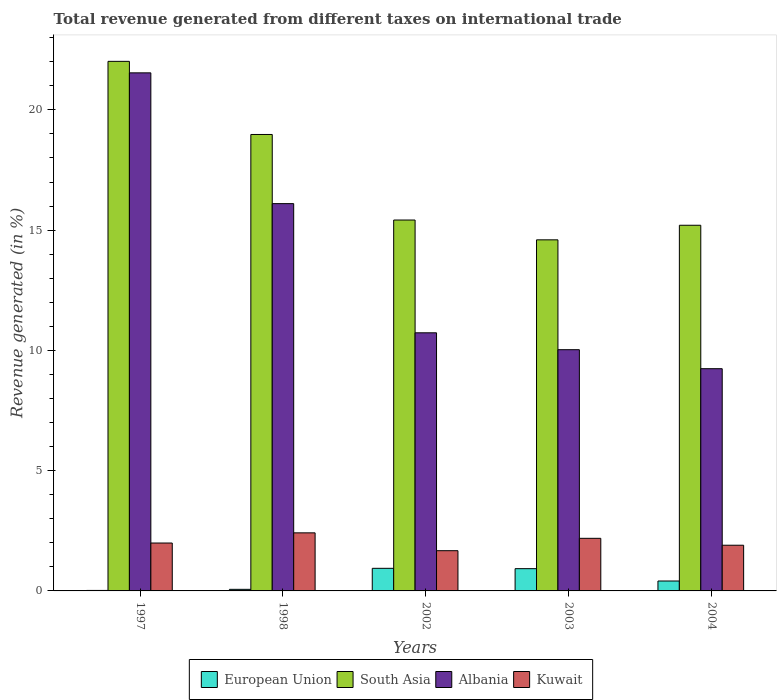How many different coloured bars are there?
Your answer should be compact. 4. How many groups of bars are there?
Provide a short and direct response. 5. Are the number of bars per tick equal to the number of legend labels?
Keep it short and to the point. Yes. How many bars are there on the 2nd tick from the left?
Ensure brevity in your answer.  4. What is the total revenue generated in South Asia in 2002?
Offer a terse response. 15.42. Across all years, what is the maximum total revenue generated in Albania?
Your answer should be compact. 21.54. Across all years, what is the minimum total revenue generated in Albania?
Offer a very short reply. 9.24. In which year was the total revenue generated in Kuwait maximum?
Provide a succinct answer. 1998. In which year was the total revenue generated in European Union minimum?
Ensure brevity in your answer.  1997. What is the total total revenue generated in South Asia in the graph?
Offer a very short reply. 86.21. What is the difference between the total revenue generated in South Asia in 1998 and that in 2004?
Your answer should be compact. 3.77. What is the difference between the total revenue generated in Albania in 2003 and the total revenue generated in South Asia in 1997?
Offer a very short reply. -11.99. What is the average total revenue generated in Kuwait per year?
Offer a very short reply. 2.03. In the year 1998, what is the difference between the total revenue generated in Albania and total revenue generated in European Union?
Offer a very short reply. 16.04. In how many years, is the total revenue generated in Kuwait greater than 20 %?
Offer a terse response. 0. What is the ratio of the total revenue generated in Albania in 2002 to that in 2003?
Your response must be concise. 1.07. What is the difference between the highest and the second highest total revenue generated in European Union?
Make the answer very short. 0.01. What is the difference between the highest and the lowest total revenue generated in South Asia?
Ensure brevity in your answer.  7.42. In how many years, is the total revenue generated in South Asia greater than the average total revenue generated in South Asia taken over all years?
Make the answer very short. 2. Is the sum of the total revenue generated in South Asia in 1997 and 2003 greater than the maximum total revenue generated in Albania across all years?
Offer a terse response. Yes. Is it the case that in every year, the sum of the total revenue generated in Kuwait and total revenue generated in European Union is greater than the sum of total revenue generated in Albania and total revenue generated in South Asia?
Offer a very short reply. Yes. What does the 1st bar from the left in 1998 represents?
Your answer should be compact. European Union. How many bars are there?
Provide a short and direct response. 20. What is the difference between two consecutive major ticks on the Y-axis?
Make the answer very short. 5. Does the graph contain any zero values?
Your answer should be compact. No. Where does the legend appear in the graph?
Your answer should be compact. Bottom center. How many legend labels are there?
Offer a very short reply. 4. How are the legend labels stacked?
Offer a very short reply. Horizontal. What is the title of the graph?
Your answer should be compact. Total revenue generated from different taxes on international trade. What is the label or title of the X-axis?
Keep it short and to the point. Years. What is the label or title of the Y-axis?
Your answer should be very brief. Revenue generated (in %). What is the Revenue generated (in %) in European Union in 1997?
Your answer should be compact. 0.02. What is the Revenue generated (in %) of South Asia in 1997?
Ensure brevity in your answer.  22.02. What is the Revenue generated (in %) in Albania in 1997?
Give a very brief answer. 21.54. What is the Revenue generated (in %) of Kuwait in 1997?
Your response must be concise. 1.99. What is the Revenue generated (in %) of European Union in 1998?
Your answer should be very brief. 0.07. What is the Revenue generated (in %) in South Asia in 1998?
Ensure brevity in your answer.  18.98. What is the Revenue generated (in %) in Albania in 1998?
Give a very brief answer. 16.1. What is the Revenue generated (in %) in Kuwait in 1998?
Provide a succinct answer. 2.41. What is the Revenue generated (in %) in European Union in 2002?
Offer a very short reply. 0.94. What is the Revenue generated (in %) of South Asia in 2002?
Provide a short and direct response. 15.42. What is the Revenue generated (in %) in Albania in 2002?
Provide a succinct answer. 10.73. What is the Revenue generated (in %) in Kuwait in 2002?
Ensure brevity in your answer.  1.67. What is the Revenue generated (in %) of European Union in 2003?
Give a very brief answer. 0.93. What is the Revenue generated (in %) in South Asia in 2003?
Give a very brief answer. 14.6. What is the Revenue generated (in %) of Albania in 2003?
Offer a very short reply. 10.03. What is the Revenue generated (in %) of Kuwait in 2003?
Make the answer very short. 2.19. What is the Revenue generated (in %) in European Union in 2004?
Provide a succinct answer. 0.41. What is the Revenue generated (in %) in South Asia in 2004?
Offer a very short reply. 15.2. What is the Revenue generated (in %) of Albania in 2004?
Your answer should be very brief. 9.24. What is the Revenue generated (in %) of Kuwait in 2004?
Your answer should be very brief. 1.9. Across all years, what is the maximum Revenue generated (in %) of European Union?
Provide a short and direct response. 0.94. Across all years, what is the maximum Revenue generated (in %) of South Asia?
Provide a succinct answer. 22.02. Across all years, what is the maximum Revenue generated (in %) in Albania?
Your answer should be very brief. 21.54. Across all years, what is the maximum Revenue generated (in %) in Kuwait?
Provide a short and direct response. 2.41. Across all years, what is the minimum Revenue generated (in %) of European Union?
Your answer should be compact. 0.02. Across all years, what is the minimum Revenue generated (in %) of South Asia?
Keep it short and to the point. 14.6. Across all years, what is the minimum Revenue generated (in %) of Albania?
Offer a terse response. 9.24. Across all years, what is the minimum Revenue generated (in %) in Kuwait?
Make the answer very short. 1.67. What is the total Revenue generated (in %) in European Union in the graph?
Provide a short and direct response. 2.36. What is the total Revenue generated (in %) of South Asia in the graph?
Provide a short and direct response. 86.21. What is the total Revenue generated (in %) in Albania in the graph?
Give a very brief answer. 67.64. What is the total Revenue generated (in %) in Kuwait in the graph?
Your response must be concise. 10.16. What is the difference between the Revenue generated (in %) of European Union in 1997 and that in 1998?
Give a very brief answer. -0.05. What is the difference between the Revenue generated (in %) of South Asia in 1997 and that in 1998?
Keep it short and to the point. 3.04. What is the difference between the Revenue generated (in %) in Albania in 1997 and that in 1998?
Your answer should be compact. 5.44. What is the difference between the Revenue generated (in %) in Kuwait in 1997 and that in 1998?
Offer a terse response. -0.42. What is the difference between the Revenue generated (in %) of European Union in 1997 and that in 2002?
Your answer should be very brief. -0.92. What is the difference between the Revenue generated (in %) in South Asia in 1997 and that in 2002?
Offer a very short reply. 6.6. What is the difference between the Revenue generated (in %) of Albania in 1997 and that in 2002?
Ensure brevity in your answer.  10.81. What is the difference between the Revenue generated (in %) in Kuwait in 1997 and that in 2002?
Your response must be concise. 0.32. What is the difference between the Revenue generated (in %) in European Union in 1997 and that in 2003?
Offer a terse response. -0.9. What is the difference between the Revenue generated (in %) of South Asia in 1997 and that in 2003?
Ensure brevity in your answer.  7.42. What is the difference between the Revenue generated (in %) of Albania in 1997 and that in 2003?
Offer a terse response. 11.51. What is the difference between the Revenue generated (in %) in Kuwait in 1997 and that in 2003?
Your response must be concise. -0.2. What is the difference between the Revenue generated (in %) in European Union in 1997 and that in 2004?
Your answer should be compact. -0.39. What is the difference between the Revenue generated (in %) in South Asia in 1997 and that in 2004?
Provide a succinct answer. 6.81. What is the difference between the Revenue generated (in %) in Albania in 1997 and that in 2004?
Your answer should be compact. 12.3. What is the difference between the Revenue generated (in %) in Kuwait in 1997 and that in 2004?
Your answer should be compact. 0.09. What is the difference between the Revenue generated (in %) in European Union in 1998 and that in 2002?
Ensure brevity in your answer.  -0.87. What is the difference between the Revenue generated (in %) in South Asia in 1998 and that in 2002?
Give a very brief answer. 3.56. What is the difference between the Revenue generated (in %) of Albania in 1998 and that in 2002?
Keep it short and to the point. 5.37. What is the difference between the Revenue generated (in %) of Kuwait in 1998 and that in 2002?
Offer a terse response. 0.74. What is the difference between the Revenue generated (in %) in European Union in 1998 and that in 2003?
Offer a terse response. -0.86. What is the difference between the Revenue generated (in %) of South Asia in 1998 and that in 2003?
Make the answer very short. 4.38. What is the difference between the Revenue generated (in %) in Albania in 1998 and that in 2003?
Your answer should be very brief. 6.07. What is the difference between the Revenue generated (in %) in Kuwait in 1998 and that in 2003?
Your answer should be very brief. 0.23. What is the difference between the Revenue generated (in %) in European Union in 1998 and that in 2004?
Your answer should be compact. -0.35. What is the difference between the Revenue generated (in %) in South Asia in 1998 and that in 2004?
Your response must be concise. 3.77. What is the difference between the Revenue generated (in %) of Albania in 1998 and that in 2004?
Make the answer very short. 6.86. What is the difference between the Revenue generated (in %) of Kuwait in 1998 and that in 2004?
Provide a succinct answer. 0.51. What is the difference between the Revenue generated (in %) in European Union in 2002 and that in 2003?
Your answer should be very brief. 0.01. What is the difference between the Revenue generated (in %) of South Asia in 2002 and that in 2003?
Offer a terse response. 0.82. What is the difference between the Revenue generated (in %) of Albania in 2002 and that in 2003?
Keep it short and to the point. 0.7. What is the difference between the Revenue generated (in %) of Kuwait in 2002 and that in 2003?
Your answer should be very brief. -0.52. What is the difference between the Revenue generated (in %) in European Union in 2002 and that in 2004?
Give a very brief answer. 0.53. What is the difference between the Revenue generated (in %) in South Asia in 2002 and that in 2004?
Your response must be concise. 0.22. What is the difference between the Revenue generated (in %) in Albania in 2002 and that in 2004?
Offer a very short reply. 1.49. What is the difference between the Revenue generated (in %) of Kuwait in 2002 and that in 2004?
Offer a terse response. -0.23. What is the difference between the Revenue generated (in %) in European Union in 2003 and that in 2004?
Your response must be concise. 0.51. What is the difference between the Revenue generated (in %) in South Asia in 2003 and that in 2004?
Keep it short and to the point. -0.61. What is the difference between the Revenue generated (in %) in Albania in 2003 and that in 2004?
Offer a terse response. 0.79. What is the difference between the Revenue generated (in %) in Kuwait in 2003 and that in 2004?
Your answer should be very brief. 0.29. What is the difference between the Revenue generated (in %) of European Union in 1997 and the Revenue generated (in %) of South Asia in 1998?
Provide a succinct answer. -18.96. What is the difference between the Revenue generated (in %) of European Union in 1997 and the Revenue generated (in %) of Albania in 1998?
Your answer should be very brief. -16.08. What is the difference between the Revenue generated (in %) of European Union in 1997 and the Revenue generated (in %) of Kuwait in 1998?
Offer a very short reply. -2.39. What is the difference between the Revenue generated (in %) of South Asia in 1997 and the Revenue generated (in %) of Albania in 1998?
Offer a very short reply. 5.92. What is the difference between the Revenue generated (in %) in South Asia in 1997 and the Revenue generated (in %) in Kuwait in 1998?
Your response must be concise. 19.6. What is the difference between the Revenue generated (in %) in Albania in 1997 and the Revenue generated (in %) in Kuwait in 1998?
Keep it short and to the point. 19.12. What is the difference between the Revenue generated (in %) of European Union in 1997 and the Revenue generated (in %) of South Asia in 2002?
Provide a short and direct response. -15.4. What is the difference between the Revenue generated (in %) of European Union in 1997 and the Revenue generated (in %) of Albania in 2002?
Offer a very short reply. -10.71. What is the difference between the Revenue generated (in %) in European Union in 1997 and the Revenue generated (in %) in Kuwait in 2002?
Ensure brevity in your answer.  -1.65. What is the difference between the Revenue generated (in %) in South Asia in 1997 and the Revenue generated (in %) in Albania in 2002?
Provide a succinct answer. 11.29. What is the difference between the Revenue generated (in %) of South Asia in 1997 and the Revenue generated (in %) of Kuwait in 2002?
Provide a succinct answer. 20.34. What is the difference between the Revenue generated (in %) in Albania in 1997 and the Revenue generated (in %) in Kuwait in 2002?
Provide a short and direct response. 19.87. What is the difference between the Revenue generated (in %) in European Union in 1997 and the Revenue generated (in %) in South Asia in 2003?
Provide a succinct answer. -14.58. What is the difference between the Revenue generated (in %) of European Union in 1997 and the Revenue generated (in %) of Albania in 2003?
Your response must be concise. -10.01. What is the difference between the Revenue generated (in %) of European Union in 1997 and the Revenue generated (in %) of Kuwait in 2003?
Ensure brevity in your answer.  -2.17. What is the difference between the Revenue generated (in %) in South Asia in 1997 and the Revenue generated (in %) in Albania in 2003?
Your answer should be very brief. 11.99. What is the difference between the Revenue generated (in %) of South Asia in 1997 and the Revenue generated (in %) of Kuwait in 2003?
Your answer should be compact. 19.83. What is the difference between the Revenue generated (in %) of Albania in 1997 and the Revenue generated (in %) of Kuwait in 2003?
Your answer should be compact. 19.35. What is the difference between the Revenue generated (in %) in European Union in 1997 and the Revenue generated (in %) in South Asia in 2004?
Give a very brief answer. -15.18. What is the difference between the Revenue generated (in %) of European Union in 1997 and the Revenue generated (in %) of Albania in 2004?
Offer a terse response. -9.22. What is the difference between the Revenue generated (in %) in European Union in 1997 and the Revenue generated (in %) in Kuwait in 2004?
Your response must be concise. -1.88. What is the difference between the Revenue generated (in %) in South Asia in 1997 and the Revenue generated (in %) in Albania in 2004?
Give a very brief answer. 12.78. What is the difference between the Revenue generated (in %) in South Asia in 1997 and the Revenue generated (in %) in Kuwait in 2004?
Ensure brevity in your answer.  20.12. What is the difference between the Revenue generated (in %) of Albania in 1997 and the Revenue generated (in %) of Kuwait in 2004?
Offer a very short reply. 19.64. What is the difference between the Revenue generated (in %) in European Union in 1998 and the Revenue generated (in %) in South Asia in 2002?
Offer a terse response. -15.35. What is the difference between the Revenue generated (in %) in European Union in 1998 and the Revenue generated (in %) in Albania in 2002?
Offer a very short reply. -10.66. What is the difference between the Revenue generated (in %) in European Union in 1998 and the Revenue generated (in %) in Kuwait in 2002?
Offer a terse response. -1.61. What is the difference between the Revenue generated (in %) of South Asia in 1998 and the Revenue generated (in %) of Albania in 2002?
Your response must be concise. 8.25. What is the difference between the Revenue generated (in %) in South Asia in 1998 and the Revenue generated (in %) in Kuwait in 2002?
Keep it short and to the point. 17.3. What is the difference between the Revenue generated (in %) of Albania in 1998 and the Revenue generated (in %) of Kuwait in 2002?
Give a very brief answer. 14.43. What is the difference between the Revenue generated (in %) of European Union in 1998 and the Revenue generated (in %) of South Asia in 2003?
Make the answer very short. -14.53. What is the difference between the Revenue generated (in %) of European Union in 1998 and the Revenue generated (in %) of Albania in 2003?
Your response must be concise. -9.96. What is the difference between the Revenue generated (in %) of European Union in 1998 and the Revenue generated (in %) of Kuwait in 2003?
Offer a very short reply. -2.12. What is the difference between the Revenue generated (in %) of South Asia in 1998 and the Revenue generated (in %) of Albania in 2003?
Provide a short and direct response. 8.95. What is the difference between the Revenue generated (in %) of South Asia in 1998 and the Revenue generated (in %) of Kuwait in 2003?
Make the answer very short. 16.79. What is the difference between the Revenue generated (in %) of Albania in 1998 and the Revenue generated (in %) of Kuwait in 2003?
Provide a succinct answer. 13.91. What is the difference between the Revenue generated (in %) in European Union in 1998 and the Revenue generated (in %) in South Asia in 2004?
Keep it short and to the point. -15.14. What is the difference between the Revenue generated (in %) of European Union in 1998 and the Revenue generated (in %) of Albania in 2004?
Your answer should be very brief. -9.17. What is the difference between the Revenue generated (in %) of European Union in 1998 and the Revenue generated (in %) of Kuwait in 2004?
Keep it short and to the point. -1.83. What is the difference between the Revenue generated (in %) of South Asia in 1998 and the Revenue generated (in %) of Albania in 2004?
Keep it short and to the point. 9.74. What is the difference between the Revenue generated (in %) in South Asia in 1998 and the Revenue generated (in %) in Kuwait in 2004?
Your answer should be very brief. 17.08. What is the difference between the Revenue generated (in %) of Albania in 1998 and the Revenue generated (in %) of Kuwait in 2004?
Give a very brief answer. 14.2. What is the difference between the Revenue generated (in %) in European Union in 2002 and the Revenue generated (in %) in South Asia in 2003?
Give a very brief answer. -13.66. What is the difference between the Revenue generated (in %) of European Union in 2002 and the Revenue generated (in %) of Albania in 2003?
Make the answer very short. -9.09. What is the difference between the Revenue generated (in %) of European Union in 2002 and the Revenue generated (in %) of Kuwait in 2003?
Give a very brief answer. -1.25. What is the difference between the Revenue generated (in %) of South Asia in 2002 and the Revenue generated (in %) of Albania in 2003?
Keep it short and to the point. 5.39. What is the difference between the Revenue generated (in %) in South Asia in 2002 and the Revenue generated (in %) in Kuwait in 2003?
Your answer should be very brief. 13.23. What is the difference between the Revenue generated (in %) in Albania in 2002 and the Revenue generated (in %) in Kuwait in 2003?
Keep it short and to the point. 8.54. What is the difference between the Revenue generated (in %) of European Union in 2002 and the Revenue generated (in %) of South Asia in 2004?
Ensure brevity in your answer.  -14.26. What is the difference between the Revenue generated (in %) of European Union in 2002 and the Revenue generated (in %) of Albania in 2004?
Your response must be concise. -8.3. What is the difference between the Revenue generated (in %) of European Union in 2002 and the Revenue generated (in %) of Kuwait in 2004?
Make the answer very short. -0.96. What is the difference between the Revenue generated (in %) in South Asia in 2002 and the Revenue generated (in %) in Albania in 2004?
Ensure brevity in your answer.  6.18. What is the difference between the Revenue generated (in %) in South Asia in 2002 and the Revenue generated (in %) in Kuwait in 2004?
Offer a terse response. 13.52. What is the difference between the Revenue generated (in %) of Albania in 2002 and the Revenue generated (in %) of Kuwait in 2004?
Ensure brevity in your answer.  8.83. What is the difference between the Revenue generated (in %) in European Union in 2003 and the Revenue generated (in %) in South Asia in 2004?
Your answer should be very brief. -14.28. What is the difference between the Revenue generated (in %) of European Union in 2003 and the Revenue generated (in %) of Albania in 2004?
Offer a terse response. -8.31. What is the difference between the Revenue generated (in %) of European Union in 2003 and the Revenue generated (in %) of Kuwait in 2004?
Provide a succinct answer. -0.97. What is the difference between the Revenue generated (in %) in South Asia in 2003 and the Revenue generated (in %) in Albania in 2004?
Offer a very short reply. 5.36. What is the difference between the Revenue generated (in %) in South Asia in 2003 and the Revenue generated (in %) in Kuwait in 2004?
Your response must be concise. 12.7. What is the difference between the Revenue generated (in %) of Albania in 2003 and the Revenue generated (in %) of Kuwait in 2004?
Provide a succinct answer. 8.13. What is the average Revenue generated (in %) of European Union per year?
Keep it short and to the point. 0.47. What is the average Revenue generated (in %) of South Asia per year?
Offer a very short reply. 17.24. What is the average Revenue generated (in %) of Albania per year?
Offer a very short reply. 13.53. What is the average Revenue generated (in %) of Kuwait per year?
Keep it short and to the point. 2.03. In the year 1997, what is the difference between the Revenue generated (in %) in European Union and Revenue generated (in %) in South Asia?
Your response must be concise. -22. In the year 1997, what is the difference between the Revenue generated (in %) of European Union and Revenue generated (in %) of Albania?
Provide a short and direct response. -21.52. In the year 1997, what is the difference between the Revenue generated (in %) of European Union and Revenue generated (in %) of Kuwait?
Your answer should be very brief. -1.97. In the year 1997, what is the difference between the Revenue generated (in %) in South Asia and Revenue generated (in %) in Albania?
Offer a terse response. 0.48. In the year 1997, what is the difference between the Revenue generated (in %) of South Asia and Revenue generated (in %) of Kuwait?
Your answer should be very brief. 20.03. In the year 1997, what is the difference between the Revenue generated (in %) of Albania and Revenue generated (in %) of Kuwait?
Offer a terse response. 19.55. In the year 1998, what is the difference between the Revenue generated (in %) in European Union and Revenue generated (in %) in South Asia?
Your response must be concise. -18.91. In the year 1998, what is the difference between the Revenue generated (in %) in European Union and Revenue generated (in %) in Albania?
Give a very brief answer. -16.04. In the year 1998, what is the difference between the Revenue generated (in %) of European Union and Revenue generated (in %) of Kuwait?
Provide a succinct answer. -2.35. In the year 1998, what is the difference between the Revenue generated (in %) in South Asia and Revenue generated (in %) in Albania?
Offer a very short reply. 2.88. In the year 1998, what is the difference between the Revenue generated (in %) of South Asia and Revenue generated (in %) of Kuwait?
Ensure brevity in your answer.  16.56. In the year 1998, what is the difference between the Revenue generated (in %) of Albania and Revenue generated (in %) of Kuwait?
Your answer should be very brief. 13.69. In the year 2002, what is the difference between the Revenue generated (in %) of European Union and Revenue generated (in %) of South Asia?
Provide a succinct answer. -14.48. In the year 2002, what is the difference between the Revenue generated (in %) of European Union and Revenue generated (in %) of Albania?
Provide a succinct answer. -9.79. In the year 2002, what is the difference between the Revenue generated (in %) of European Union and Revenue generated (in %) of Kuwait?
Offer a terse response. -0.73. In the year 2002, what is the difference between the Revenue generated (in %) of South Asia and Revenue generated (in %) of Albania?
Provide a short and direct response. 4.69. In the year 2002, what is the difference between the Revenue generated (in %) in South Asia and Revenue generated (in %) in Kuwait?
Your answer should be compact. 13.75. In the year 2002, what is the difference between the Revenue generated (in %) of Albania and Revenue generated (in %) of Kuwait?
Give a very brief answer. 9.06. In the year 2003, what is the difference between the Revenue generated (in %) in European Union and Revenue generated (in %) in South Asia?
Your answer should be very brief. -13.67. In the year 2003, what is the difference between the Revenue generated (in %) in European Union and Revenue generated (in %) in Albania?
Keep it short and to the point. -9.1. In the year 2003, what is the difference between the Revenue generated (in %) of European Union and Revenue generated (in %) of Kuwait?
Ensure brevity in your answer.  -1.26. In the year 2003, what is the difference between the Revenue generated (in %) of South Asia and Revenue generated (in %) of Albania?
Offer a terse response. 4.57. In the year 2003, what is the difference between the Revenue generated (in %) of South Asia and Revenue generated (in %) of Kuwait?
Your response must be concise. 12.41. In the year 2003, what is the difference between the Revenue generated (in %) in Albania and Revenue generated (in %) in Kuwait?
Your answer should be compact. 7.84. In the year 2004, what is the difference between the Revenue generated (in %) of European Union and Revenue generated (in %) of South Asia?
Provide a succinct answer. -14.79. In the year 2004, what is the difference between the Revenue generated (in %) in European Union and Revenue generated (in %) in Albania?
Provide a short and direct response. -8.83. In the year 2004, what is the difference between the Revenue generated (in %) in European Union and Revenue generated (in %) in Kuwait?
Ensure brevity in your answer.  -1.49. In the year 2004, what is the difference between the Revenue generated (in %) in South Asia and Revenue generated (in %) in Albania?
Make the answer very short. 5.96. In the year 2004, what is the difference between the Revenue generated (in %) of South Asia and Revenue generated (in %) of Kuwait?
Your answer should be very brief. 13.3. In the year 2004, what is the difference between the Revenue generated (in %) of Albania and Revenue generated (in %) of Kuwait?
Provide a short and direct response. 7.34. What is the ratio of the Revenue generated (in %) in European Union in 1997 to that in 1998?
Make the answer very short. 0.31. What is the ratio of the Revenue generated (in %) of South Asia in 1997 to that in 1998?
Provide a succinct answer. 1.16. What is the ratio of the Revenue generated (in %) of Albania in 1997 to that in 1998?
Give a very brief answer. 1.34. What is the ratio of the Revenue generated (in %) of Kuwait in 1997 to that in 1998?
Provide a succinct answer. 0.82. What is the ratio of the Revenue generated (in %) in European Union in 1997 to that in 2002?
Give a very brief answer. 0.02. What is the ratio of the Revenue generated (in %) in South Asia in 1997 to that in 2002?
Keep it short and to the point. 1.43. What is the ratio of the Revenue generated (in %) of Albania in 1997 to that in 2002?
Provide a succinct answer. 2.01. What is the ratio of the Revenue generated (in %) in Kuwait in 1997 to that in 2002?
Your response must be concise. 1.19. What is the ratio of the Revenue generated (in %) of European Union in 1997 to that in 2003?
Offer a very short reply. 0.02. What is the ratio of the Revenue generated (in %) of South Asia in 1997 to that in 2003?
Your response must be concise. 1.51. What is the ratio of the Revenue generated (in %) of Albania in 1997 to that in 2003?
Offer a terse response. 2.15. What is the ratio of the Revenue generated (in %) of Kuwait in 1997 to that in 2003?
Your answer should be compact. 0.91. What is the ratio of the Revenue generated (in %) in European Union in 1997 to that in 2004?
Make the answer very short. 0.05. What is the ratio of the Revenue generated (in %) in South Asia in 1997 to that in 2004?
Provide a short and direct response. 1.45. What is the ratio of the Revenue generated (in %) of Albania in 1997 to that in 2004?
Ensure brevity in your answer.  2.33. What is the ratio of the Revenue generated (in %) of Kuwait in 1997 to that in 2004?
Your response must be concise. 1.05. What is the ratio of the Revenue generated (in %) of European Union in 1998 to that in 2002?
Provide a succinct answer. 0.07. What is the ratio of the Revenue generated (in %) of South Asia in 1998 to that in 2002?
Give a very brief answer. 1.23. What is the ratio of the Revenue generated (in %) of Albania in 1998 to that in 2002?
Keep it short and to the point. 1.5. What is the ratio of the Revenue generated (in %) in Kuwait in 1998 to that in 2002?
Keep it short and to the point. 1.44. What is the ratio of the Revenue generated (in %) in European Union in 1998 to that in 2003?
Keep it short and to the point. 0.07. What is the ratio of the Revenue generated (in %) in South Asia in 1998 to that in 2003?
Give a very brief answer. 1.3. What is the ratio of the Revenue generated (in %) of Albania in 1998 to that in 2003?
Your response must be concise. 1.61. What is the ratio of the Revenue generated (in %) of Kuwait in 1998 to that in 2003?
Offer a very short reply. 1.1. What is the ratio of the Revenue generated (in %) of European Union in 1998 to that in 2004?
Offer a terse response. 0.16. What is the ratio of the Revenue generated (in %) of South Asia in 1998 to that in 2004?
Your response must be concise. 1.25. What is the ratio of the Revenue generated (in %) of Albania in 1998 to that in 2004?
Offer a terse response. 1.74. What is the ratio of the Revenue generated (in %) in Kuwait in 1998 to that in 2004?
Ensure brevity in your answer.  1.27. What is the ratio of the Revenue generated (in %) in European Union in 2002 to that in 2003?
Make the answer very short. 1.02. What is the ratio of the Revenue generated (in %) of South Asia in 2002 to that in 2003?
Make the answer very short. 1.06. What is the ratio of the Revenue generated (in %) in Albania in 2002 to that in 2003?
Keep it short and to the point. 1.07. What is the ratio of the Revenue generated (in %) of Kuwait in 2002 to that in 2003?
Your answer should be compact. 0.76. What is the ratio of the Revenue generated (in %) in European Union in 2002 to that in 2004?
Make the answer very short. 2.28. What is the ratio of the Revenue generated (in %) in South Asia in 2002 to that in 2004?
Offer a terse response. 1.01. What is the ratio of the Revenue generated (in %) in Albania in 2002 to that in 2004?
Provide a short and direct response. 1.16. What is the ratio of the Revenue generated (in %) of Kuwait in 2002 to that in 2004?
Give a very brief answer. 0.88. What is the ratio of the Revenue generated (in %) of European Union in 2003 to that in 2004?
Give a very brief answer. 2.25. What is the ratio of the Revenue generated (in %) of South Asia in 2003 to that in 2004?
Offer a very short reply. 0.96. What is the ratio of the Revenue generated (in %) of Albania in 2003 to that in 2004?
Provide a succinct answer. 1.09. What is the ratio of the Revenue generated (in %) of Kuwait in 2003 to that in 2004?
Your response must be concise. 1.15. What is the difference between the highest and the second highest Revenue generated (in %) of European Union?
Provide a succinct answer. 0.01. What is the difference between the highest and the second highest Revenue generated (in %) in South Asia?
Give a very brief answer. 3.04. What is the difference between the highest and the second highest Revenue generated (in %) in Albania?
Provide a short and direct response. 5.44. What is the difference between the highest and the second highest Revenue generated (in %) of Kuwait?
Provide a short and direct response. 0.23. What is the difference between the highest and the lowest Revenue generated (in %) in European Union?
Offer a terse response. 0.92. What is the difference between the highest and the lowest Revenue generated (in %) in South Asia?
Give a very brief answer. 7.42. What is the difference between the highest and the lowest Revenue generated (in %) in Albania?
Make the answer very short. 12.3. What is the difference between the highest and the lowest Revenue generated (in %) in Kuwait?
Ensure brevity in your answer.  0.74. 